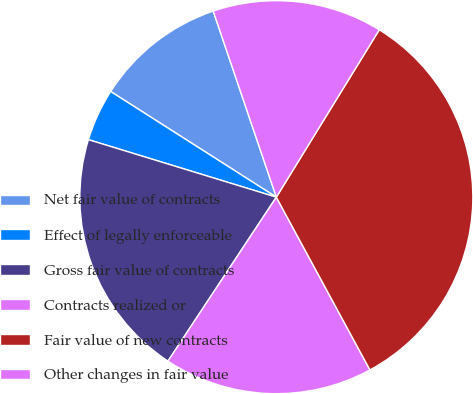Convert chart to OTSL. <chart><loc_0><loc_0><loc_500><loc_500><pie_chart><fcel>Net fair value of contracts<fcel>Effect of legally enforceable<fcel>Gross fair value of contracts<fcel>Contracts realized or<fcel>Fair value of new contracts<fcel>Other changes in fair value<nl><fcel>10.76%<fcel>4.31%<fcel>20.43%<fcel>17.2%<fcel>33.32%<fcel>13.98%<nl></chart> 